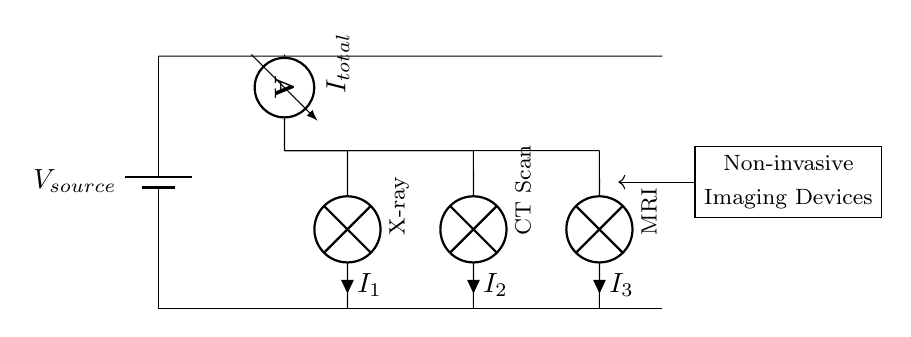What is the type of circuit shown in the diagram? The diagram illustrates a parallel circuit, where multiple devices connect across the same two voltage points.
Answer: parallel What is the voltage source labeled in the circuit? The voltage source is labeled V_{source}, indicating it is the primary power supply for the circuit.
Answer: V_{source} How many imaging devices are represented in the circuit? There are three imaging devices displayed: X-ray, CT Scan, and MRI, all connected in parallel.
Answer: three What does the ammeter measure in the circuit? The ammeter measures the total current flowing through the circuit, given by the label I_{total}.
Answer: total current What is the current through the MRI device? The current through the MRI device is indicated by the label I_{3} next to the MRI component in the diagram.
Answer: I_{3} Why is the circuit arranged in parallel for these devices? A parallel arrangement allows each imaging device to operate independently and receive the same voltage, which is crucial for non-invasive imaging techniques where consistent operation is necessary.
Answer: independent operation What does the representation of the non-invasive imaging devices signify? The non-invasive imaging devices symbolize advanced methodologies used in archaeology and paleontology that do not disturb the excavation site while analyzing objects.
Answer: advanced methodologies 